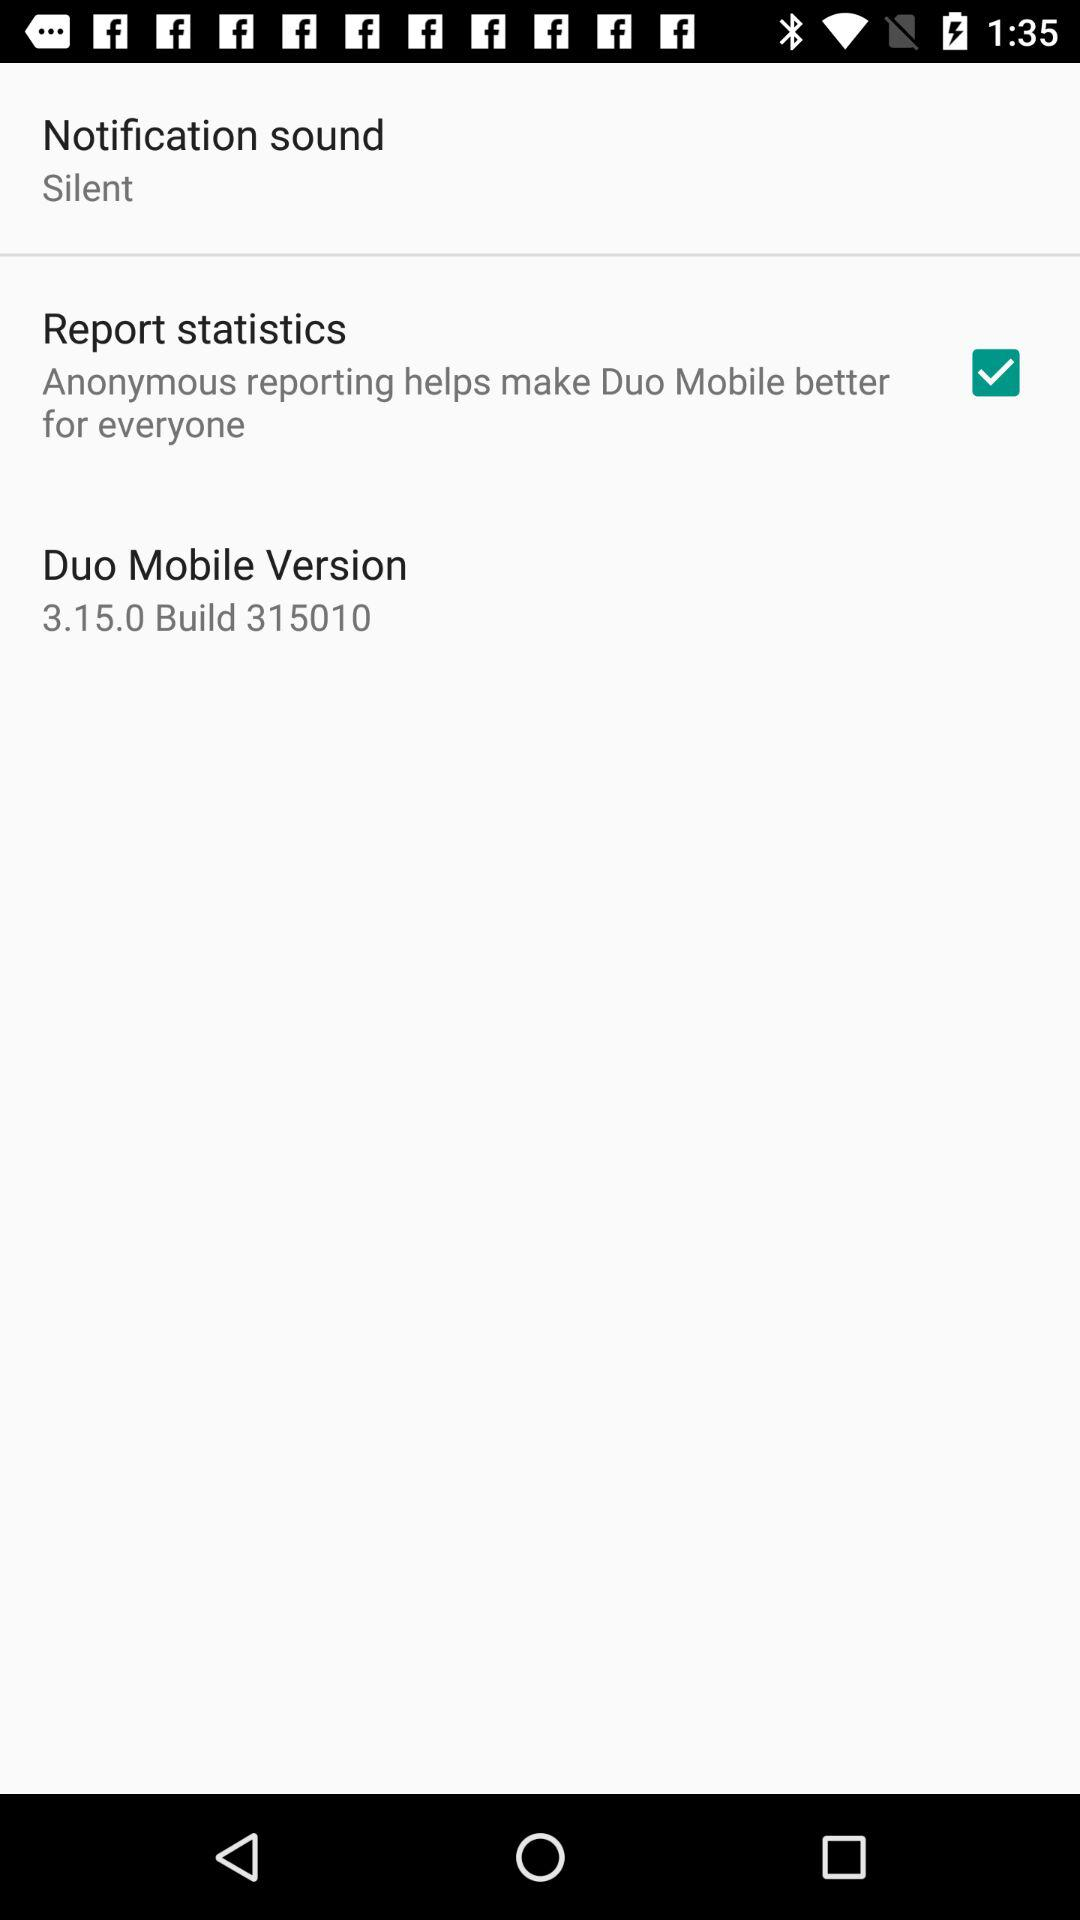What is the setting for the notification sound? The setting for the notification sound is "Silent". 